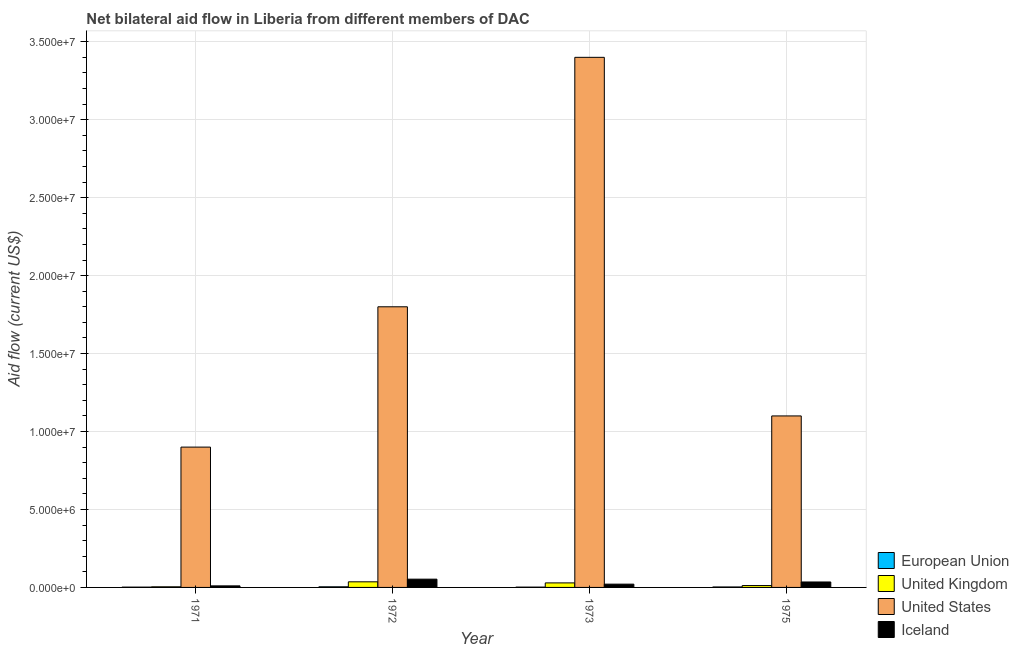How many different coloured bars are there?
Your answer should be very brief. 4. How many bars are there on the 2nd tick from the left?
Offer a very short reply. 4. How many bars are there on the 1st tick from the right?
Your answer should be compact. 4. In how many cases, is the number of bars for a given year not equal to the number of legend labels?
Provide a succinct answer. 0. What is the amount of aid given by uk in 1971?
Provide a short and direct response. 4.00e+04. Across all years, what is the maximum amount of aid given by uk?
Provide a short and direct response. 3.60e+05. Across all years, what is the minimum amount of aid given by iceland?
Give a very brief answer. 1.00e+05. What is the total amount of aid given by uk in the graph?
Keep it short and to the point. 8.10e+05. What is the difference between the amount of aid given by us in 1973 and that in 1975?
Provide a short and direct response. 2.30e+07. What is the difference between the amount of aid given by us in 1971 and the amount of aid given by eu in 1972?
Give a very brief answer. -9.00e+06. What is the average amount of aid given by iceland per year?
Your answer should be compact. 2.98e+05. In the year 1972, what is the difference between the amount of aid given by uk and amount of aid given by iceland?
Your answer should be very brief. 0. In how many years, is the amount of aid given by uk greater than 32000000 US$?
Your response must be concise. 0. What is the ratio of the amount of aid given by eu in 1971 to that in 1972?
Provide a short and direct response. 0.5. Is the difference between the amount of aid given by uk in 1973 and 1975 greater than the difference between the amount of aid given by iceland in 1973 and 1975?
Provide a succinct answer. No. What is the difference between the highest and the lowest amount of aid given by uk?
Provide a succinct answer. 3.20e+05. In how many years, is the amount of aid given by iceland greater than the average amount of aid given by iceland taken over all years?
Your response must be concise. 2. Is the sum of the amount of aid given by uk in 1972 and 1973 greater than the maximum amount of aid given by eu across all years?
Provide a succinct answer. Yes. Is it the case that in every year, the sum of the amount of aid given by us and amount of aid given by iceland is greater than the sum of amount of aid given by uk and amount of aid given by eu?
Your answer should be compact. Yes. What does the 3rd bar from the right in 1975 represents?
Offer a very short reply. United Kingdom. Is it the case that in every year, the sum of the amount of aid given by eu and amount of aid given by uk is greater than the amount of aid given by us?
Your answer should be very brief. No. How many bars are there?
Your answer should be compact. 16. How many years are there in the graph?
Provide a succinct answer. 4. What is the difference between two consecutive major ticks on the Y-axis?
Your answer should be very brief. 5.00e+06. Are the values on the major ticks of Y-axis written in scientific E-notation?
Offer a very short reply. Yes. Where does the legend appear in the graph?
Your answer should be very brief. Bottom right. How many legend labels are there?
Give a very brief answer. 4. How are the legend labels stacked?
Provide a succinct answer. Vertical. What is the title of the graph?
Give a very brief answer. Net bilateral aid flow in Liberia from different members of DAC. What is the label or title of the X-axis?
Make the answer very short. Year. What is the Aid flow (current US$) in United States in 1971?
Give a very brief answer. 9.00e+06. What is the Aid flow (current US$) in Iceland in 1971?
Give a very brief answer. 1.00e+05. What is the Aid flow (current US$) in United Kingdom in 1972?
Make the answer very short. 3.60e+05. What is the Aid flow (current US$) of United States in 1972?
Ensure brevity in your answer.  1.80e+07. What is the Aid flow (current US$) in Iceland in 1972?
Your answer should be very brief. 5.30e+05. What is the Aid flow (current US$) of European Union in 1973?
Provide a short and direct response. 2.00e+04. What is the Aid flow (current US$) of United States in 1973?
Give a very brief answer. 3.40e+07. What is the Aid flow (current US$) of Iceland in 1973?
Provide a succinct answer. 2.10e+05. What is the Aid flow (current US$) in European Union in 1975?
Your answer should be very brief. 3.00e+04. What is the Aid flow (current US$) of United Kingdom in 1975?
Offer a very short reply. 1.20e+05. What is the Aid flow (current US$) of United States in 1975?
Provide a succinct answer. 1.10e+07. Across all years, what is the maximum Aid flow (current US$) of European Union?
Provide a short and direct response. 4.00e+04. Across all years, what is the maximum Aid flow (current US$) in United States?
Make the answer very short. 3.40e+07. Across all years, what is the maximum Aid flow (current US$) of Iceland?
Provide a short and direct response. 5.30e+05. Across all years, what is the minimum Aid flow (current US$) of European Union?
Your response must be concise. 2.00e+04. Across all years, what is the minimum Aid flow (current US$) of United Kingdom?
Offer a very short reply. 4.00e+04. Across all years, what is the minimum Aid flow (current US$) in United States?
Offer a very short reply. 9.00e+06. Across all years, what is the minimum Aid flow (current US$) of Iceland?
Your answer should be very brief. 1.00e+05. What is the total Aid flow (current US$) of United Kingdom in the graph?
Keep it short and to the point. 8.10e+05. What is the total Aid flow (current US$) in United States in the graph?
Offer a very short reply. 7.20e+07. What is the total Aid flow (current US$) of Iceland in the graph?
Offer a very short reply. 1.19e+06. What is the difference between the Aid flow (current US$) of European Union in 1971 and that in 1972?
Your answer should be very brief. -2.00e+04. What is the difference between the Aid flow (current US$) of United Kingdom in 1971 and that in 1972?
Keep it short and to the point. -3.20e+05. What is the difference between the Aid flow (current US$) of United States in 1971 and that in 1972?
Offer a very short reply. -9.00e+06. What is the difference between the Aid flow (current US$) in Iceland in 1971 and that in 1972?
Keep it short and to the point. -4.30e+05. What is the difference between the Aid flow (current US$) in United States in 1971 and that in 1973?
Give a very brief answer. -2.50e+07. What is the difference between the Aid flow (current US$) of European Union in 1971 and that in 1975?
Your answer should be very brief. -10000. What is the difference between the Aid flow (current US$) of European Union in 1972 and that in 1973?
Make the answer very short. 2.00e+04. What is the difference between the Aid flow (current US$) in United States in 1972 and that in 1973?
Your answer should be compact. -1.60e+07. What is the difference between the Aid flow (current US$) of European Union in 1972 and that in 1975?
Ensure brevity in your answer.  10000. What is the difference between the Aid flow (current US$) in United Kingdom in 1972 and that in 1975?
Your answer should be very brief. 2.40e+05. What is the difference between the Aid flow (current US$) in Iceland in 1972 and that in 1975?
Offer a very short reply. 1.80e+05. What is the difference between the Aid flow (current US$) in European Union in 1973 and that in 1975?
Provide a succinct answer. -10000. What is the difference between the Aid flow (current US$) in United Kingdom in 1973 and that in 1975?
Provide a succinct answer. 1.70e+05. What is the difference between the Aid flow (current US$) of United States in 1973 and that in 1975?
Your response must be concise. 2.30e+07. What is the difference between the Aid flow (current US$) in Iceland in 1973 and that in 1975?
Provide a succinct answer. -1.40e+05. What is the difference between the Aid flow (current US$) in European Union in 1971 and the Aid flow (current US$) in United Kingdom in 1972?
Ensure brevity in your answer.  -3.40e+05. What is the difference between the Aid flow (current US$) in European Union in 1971 and the Aid flow (current US$) in United States in 1972?
Give a very brief answer. -1.80e+07. What is the difference between the Aid flow (current US$) of European Union in 1971 and the Aid flow (current US$) of Iceland in 1972?
Give a very brief answer. -5.10e+05. What is the difference between the Aid flow (current US$) in United Kingdom in 1971 and the Aid flow (current US$) in United States in 1972?
Offer a very short reply. -1.80e+07. What is the difference between the Aid flow (current US$) of United Kingdom in 1971 and the Aid flow (current US$) of Iceland in 1972?
Give a very brief answer. -4.90e+05. What is the difference between the Aid flow (current US$) of United States in 1971 and the Aid flow (current US$) of Iceland in 1972?
Offer a terse response. 8.47e+06. What is the difference between the Aid flow (current US$) of European Union in 1971 and the Aid flow (current US$) of United States in 1973?
Ensure brevity in your answer.  -3.40e+07. What is the difference between the Aid flow (current US$) in European Union in 1971 and the Aid flow (current US$) in Iceland in 1973?
Offer a very short reply. -1.90e+05. What is the difference between the Aid flow (current US$) of United Kingdom in 1971 and the Aid flow (current US$) of United States in 1973?
Make the answer very short. -3.40e+07. What is the difference between the Aid flow (current US$) of United Kingdom in 1971 and the Aid flow (current US$) of Iceland in 1973?
Provide a succinct answer. -1.70e+05. What is the difference between the Aid flow (current US$) of United States in 1971 and the Aid flow (current US$) of Iceland in 1973?
Ensure brevity in your answer.  8.79e+06. What is the difference between the Aid flow (current US$) of European Union in 1971 and the Aid flow (current US$) of United States in 1975?
Give a very brief answer. -1.10e+07. What is the difference between the Aid flow (current US$) in European Union in 1971 and the Aid flow (current US$) in Iceland in 1975?
Provide a succinct answer. -3.30e+05. What is the difference between the Aid flow (current US$) in United Kingdom in 1971 and the Aid flow (current US$) in United States in 1975?
Your answer should be very brief. -1.10e+07. What is the difference between the Aid flow (current US$) of United Kingdom in 1971 and the Aid flow (current US$) of Iceland in 1975?
Your answer should be very brief. -3.10e+05. What is the difference between the Aid flow (current US$) of United States in 1971 and the Aid flow (current US$) of Iceland in 1975?
Offer a very short reply. 8.65e+06. What is the difference between the Aid flow (current US$) in European Union in 1972 and the Aid flow (current US$) in United States in 1973?
Offer a terse response. -3.40e+07. What is the difference between the Aid flow (current US$) in United Kingdom in 1972 and the Aid flow (current US$) in United States in 1973?
Your answer should be very brief. -3.36e+07. What is the difference between the Aid flow (current US$) of United States in 1972 and the Aid flow (current US$) of Iceland in 1973?
Give a very brief answer. 1.78e+07. What is the difference between the Aid flow (current US$) of European Union in 1972 and the Aid flow (current US$) of United Kingdom in 1975?
Make the answer very short. -8.00e+04. What is the difference between the Aid flow (current US$) of European Union in 1972 and the Aid flow (current US$) of United States in 1975?
Your answer should be compact. -1.10e+07. What is the difference between the Aid flow (current US$) of European Union in 1972 and the Aid flow (current US$) of Iceland in 1975?
Ensure brevity in your answer.  -3.10e+05. What is the difference between the Aid flow (current US$) in United Kingdom in 1972 and the Aid flow (current US$) in United States in 1975?
Ensure brevity in your answer.  -1.06e+07. What is the difference between the Aid flow (current US$) of United States in 1972 and the Aid flow (current US$) of Iceland in 1975?
Keep it short and to the point. 1.76e+07. What is the difference between the Aid flow (current US$) in European Union in 1973 and the Aid flow (current US$) in United States in 1975?
Provide a succinct answer. -1.10e+07. What is the difference between the Aid flow (current US$) of European Union in 1973 and the Aid flow (current US$) of Iceland in 1975?
Offer a very short reply. -3.30e+05. What is the difference between the Aid flow (current US$) in United Kingdom in 1973 and the Aid flow (current US$) in United States in 1975?
Your answer should be compact. -1.07e+07. What is the difference between the Aid flow (current US$) of United Kingdom in 1973 and the Aid flow (current US$) of Iceland in 1975?
Keep it short and to the point. -6.00e+04. What is the difference between the Aid flow (current US$) in United States in 1973 and the Aid flow (current US$) in Iceland in 1975?
Provide a short and direct response. 3.36e+07. What is the average Aid flow (current US$) in European Union per year?
Keep it short and to the point. 2.75e+04. What is the average Aid flow (current US$) in United Kingdom per year?
Offer a very short reply. 2.02e+05. What is the average Aid flow (current US$) in United States per year?
Offer a very short reply. 1.80e+07. What is the average Aid flow (current US$) in Iceland per year?
Your answer should be compact. 2.98e+05. In the year 1971, what is the difference between the Aid flow (current US$) in European Union and Aid flow (current US$) in United Kingdom?
Offer a terse response. -2.00e+04. In the year 1971, what is the difference between the Aid flow (current US$) in European Union and Aid flow (current US$) in United States?
Your response must be concise. -8.98e+06. In the year 1971, what is the difference between the Aid flow (current US$) in European Union and Aid flow (current US$) in Iceland?
Your response must be concise. -8.00e+04. In the year 1971, what is the difference between the Aid flow (current US$) of United Kingdom and Aid flow (current US$) of United States?
Ensure brevity in your answer.  -8.96e+06. In the year 1971, what is the difference between the Aid flow (current US$) in United Kingdom and Aid flow (current US$) in Iceland?
Keep it short and to the point. -6.00e+04. In the year 1971, what is the difference between the Aid flow (current US$) of United States and Aid flow (current US$) of Iceland?
Make the answer very short. 8.90e+06. In the year 1972, what is the difference between the Aid flow (current US$) in European Union and Aid flow (current US$) in United Kingdom?
Provide a succinct answer. -3.20e+05. In the year 1972, what is the difference between the Aid flow (current US$) of European Union and Aid flow (current US$) of United States?
Your response must be concise. -1.80e+07. In the year 1972, what is the difference between the Aid flow (current US$) of European Union and Aid flow (current US$) of Iceland?
Provide a succinct answer. -4.90e+05. In the year 1972, what is the difference between the Aid flow (current US$) in United Kingdom and Aid flow (current US$) in United States?
Offer a terse response. -1.76e+07. In the year 1972, what is the difference between the Aid flow (current US$) in United Kingdom and Aid flow (current US$) in Iceland?
Give a very brief answer. -1.70e+05. In the year 1972, what is the difference between the Aid flow (current US$) of United States and Aid flow (current US$) of Iceland?
Offer a terse response. 1.75e+07. In the year 1973, what is the difference between the Aid flow (current US$) of European Union and Aid flow (current US$) of United Kingdom?
Give a very brief answer. -2.70e+05. In the year 1973, what is the difference between the Aid flow (current US$) of European Union and Aid flow (current US$) of United States?
Keep it short and to the point. -3.40e+07. In the year 1973, what is the difference between the Aid flow (current US$) in European Union and Aid flow (current US$) in Iceland?
Provide a succinct answer. -1.90e+05. In the year 1973, what is the difference between the Aid flow (current US$) in United Kingdom and Aid flow (current US$) in United States?
Keep it short and to the point. -3.37e+07. In the year 1973, what is the difference between the Aid flow (current US$) in United States and Aid flow (current US$) in Iceland?
Your response must be concise. 3.38e+07. In the year 1975, what is the difference between the Aid flow (current US$) in European Union and Aid flow (current US$) in United States?
Offer a terse response. -1.10e+07. In the year 1975, what is the difference between the Aid flow (current US$) of European Union and Aid flow (current US$) of Iceland?
Provide a short and direct response. -3.20e+05. In the year 1975, what is the difference between the Aid flow (current US$) in United Kingdom and Aid flow (current US$) in United States?
Make the answer very short. -1.09e+07. In the year 1975, what is the difference between the Aid flow (current US$) in United States and Aid flow (current US$) in Iceland?
Keep it short and to the point. 1.06e+07. What is the ratio of the Aid flow (current US$) of European Union in 1971 to that in 1972?
Your answer should be very brief. 0.5. What is the ratio of the Aid flow (current US$) in Iceland in 1971 to that in 1972?
Ensure brevity in your answer.  0.19. What is the ratio of the Aid flow (current US$) in United Kingdom in 1971 to that in 1973?
Offer a very short reply. 0.14. What is the ratio of the Aid flow (current US$) of United States in 1971 to that in 1973?
Keep it short and to the point. 0.26. What is the ratio of the Aid flow (current US$) of Iceland in 1971 to that in 1973?
Offer a terse response. 0.48. What is the ratio of the Aid flow (current US$) of European Union in 1971 to that in 1975?
Give a very brief answer. 0.67. What is the ratio of the Aid flow (current US$) in United Kingdom in 1971 to that in 1975?
Offer a terse response. 0.33. What is the ratio of the Aid flow (current US$) in United States in 1971 to that in 1975?
Your response must be concise. 0.82. What is the ratio of the Aid flow (current US$) in Iceland in 1971 to that in 1975?
Your answer should be very brief. 0.29. What is the ratio of the Aid flow (current US$) of United Kingdom in 1972 to that in 1973?
Your response must be concise. 1.24. What is the ratio of the Aid flow (current US$) in United States in 1972 to that in 1973?
Keep it short and to the point. 0.53. What is the ratio of the Aid flow (current US$) in Iceland in 1972 to that in 1973?
Your answer should be very brief. 2.52. What is the ratio of the Aid flow (current US$) in United States in 1972 to that in 1975?
Give a very brief answer. 1.64. What is the ratio of the Aid flow (current US$) in Iceland in 1972 to that in 1975?
Offer a very short reply. 1.51. What is the ratio of the Aid flow (current US$) of United Kingdom in 1973 to that in 1975?
Your response must be concise. 2.42. What is the ratio of the Aid flow (current US$) in United States in 1973 to that in 1975?
Your response must be concise. 3.09. What is the difference between the highest and the second highest Aid flow (current US$) in European Union?
Give a very brief answer. 10000. What is the difference between the highest and the second highest Aid flow (current US$) in United Kingdom?
Ensure brevity in your answer.  7.00e+04. What is the difference between the highest and the second highest Aid flow (current US$) of United States?
Make the answer very short. 1.60e+07. What is the difference between the highest and the lowest Aid flow (current US$) in European Union?
Provide a short and direct response. 2.00e+04. What is the difference between the highest and the lowest Aid flow (current US$) in United Kingdom?
Provide a short and direct response. 3.20e+05. What is the difference between the highest and the lowest Aid flow (current US$) in United States?
Make the answer very short. 2.50e+07. What is the difference between the highest and the lowest Aid flow (current US$) in Iceland?
Your answer should be compact. 4.30e+05. 